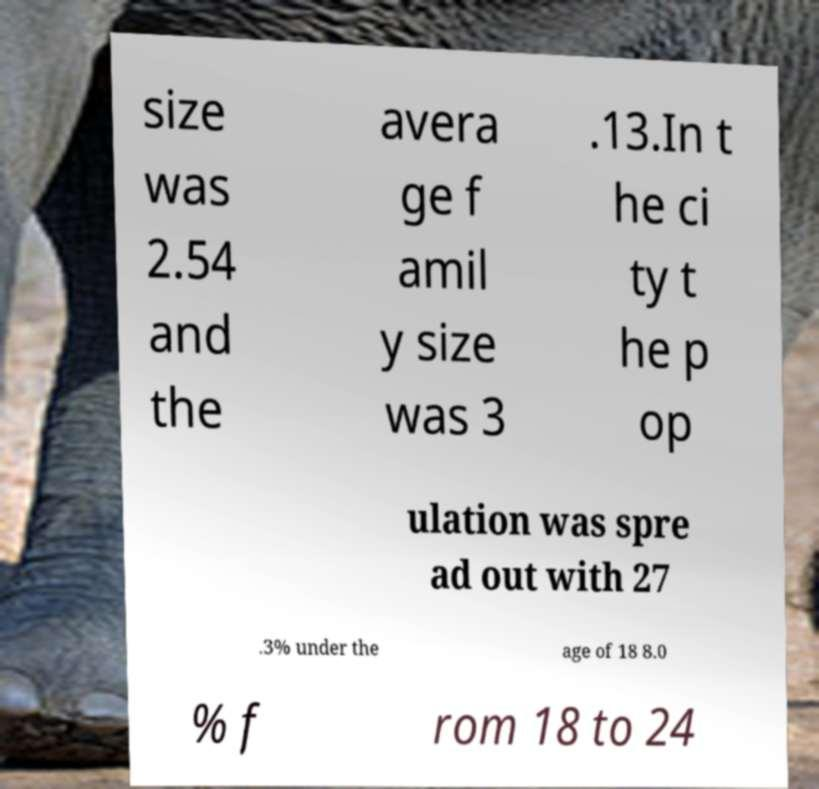Please identify and transcribe the text found in this image. size was 2.54 and the avera ge f amil y size was 3 .13.In t he ci ty t he p op ulation was spre ad out with 27 .3% under the age of 18 8.0 % f rom 18 to 24 